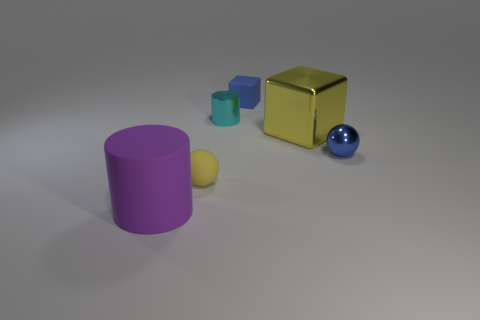Add 4 large cyan rubber objects. How many objects exist? 10 Subtract all cubes. How many objects are left? 4 Add 2 large purple things. How many large purple things are left? 3 Add 4 big red shiny things. How many big red shiny things exist? 4 Subtract 1 yellow balls. How many objects are left? 5 Subtract all purple cubes. Subtract all yellow cylinders. How many cubes are left? 2 Subtract all purple spheres. Subtract all small blue things. How many objects are left? 4 